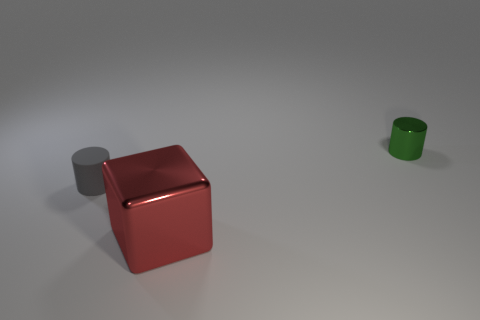How many other things are the same material as the gray thing?
Your answer should be compact. 0. There is a cylinder that is made of the same material as the large red object; what color is it?
Your response must be concise. Green. Do the metallic thing that is in front of the gray cylinder and the tiny green shiny object have the same size?
Your response must be concise. No. There is a small metal object that is the same shape as the rubber thing; what is its color?
Provide a short and direct response. Green. What shape is the object on the right side of the metal object that is left of the cylinder that is on the right side of the red metal thing?
Your response must be concise. Cylinder. Does the small metallic thing have the same shape as the big object?
Offer a very short reply. No. The metal thing that is in front of the thing to the left of the large object is what shape?
Make the answer very short. Cube. Are any tiny green metal objects visible?
Offer a terse response. Yes. How many large cubes are on the right side of the cylinder that is right of the cylinder left of the green metallic cylinder?
Offer a very short reply. 0. There is a large red object; is its shape the same as the shiny thing right of the red shiny object?
Keep it short and to the point. No. 